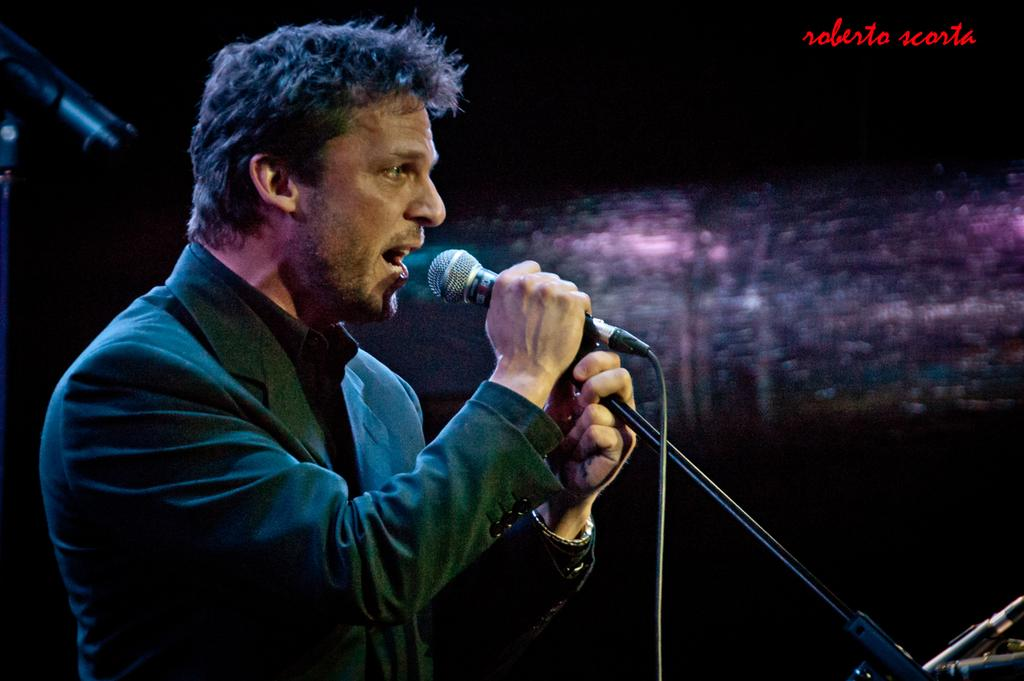What is the man in the image doing? The man is singing a song in the image. What object is the man holding while singing? The man is holding a microphone in the image. What can be observed about the background of the image? The background of the image is dark. Is there any additional information or branding on the image? Yes, there is a watermark on the image. What time does the clock in the image show? There is no clock present in the image. Can you describe the beast that is lurking in the quicksand in the image? There is no beast or quicksand present in the image. 